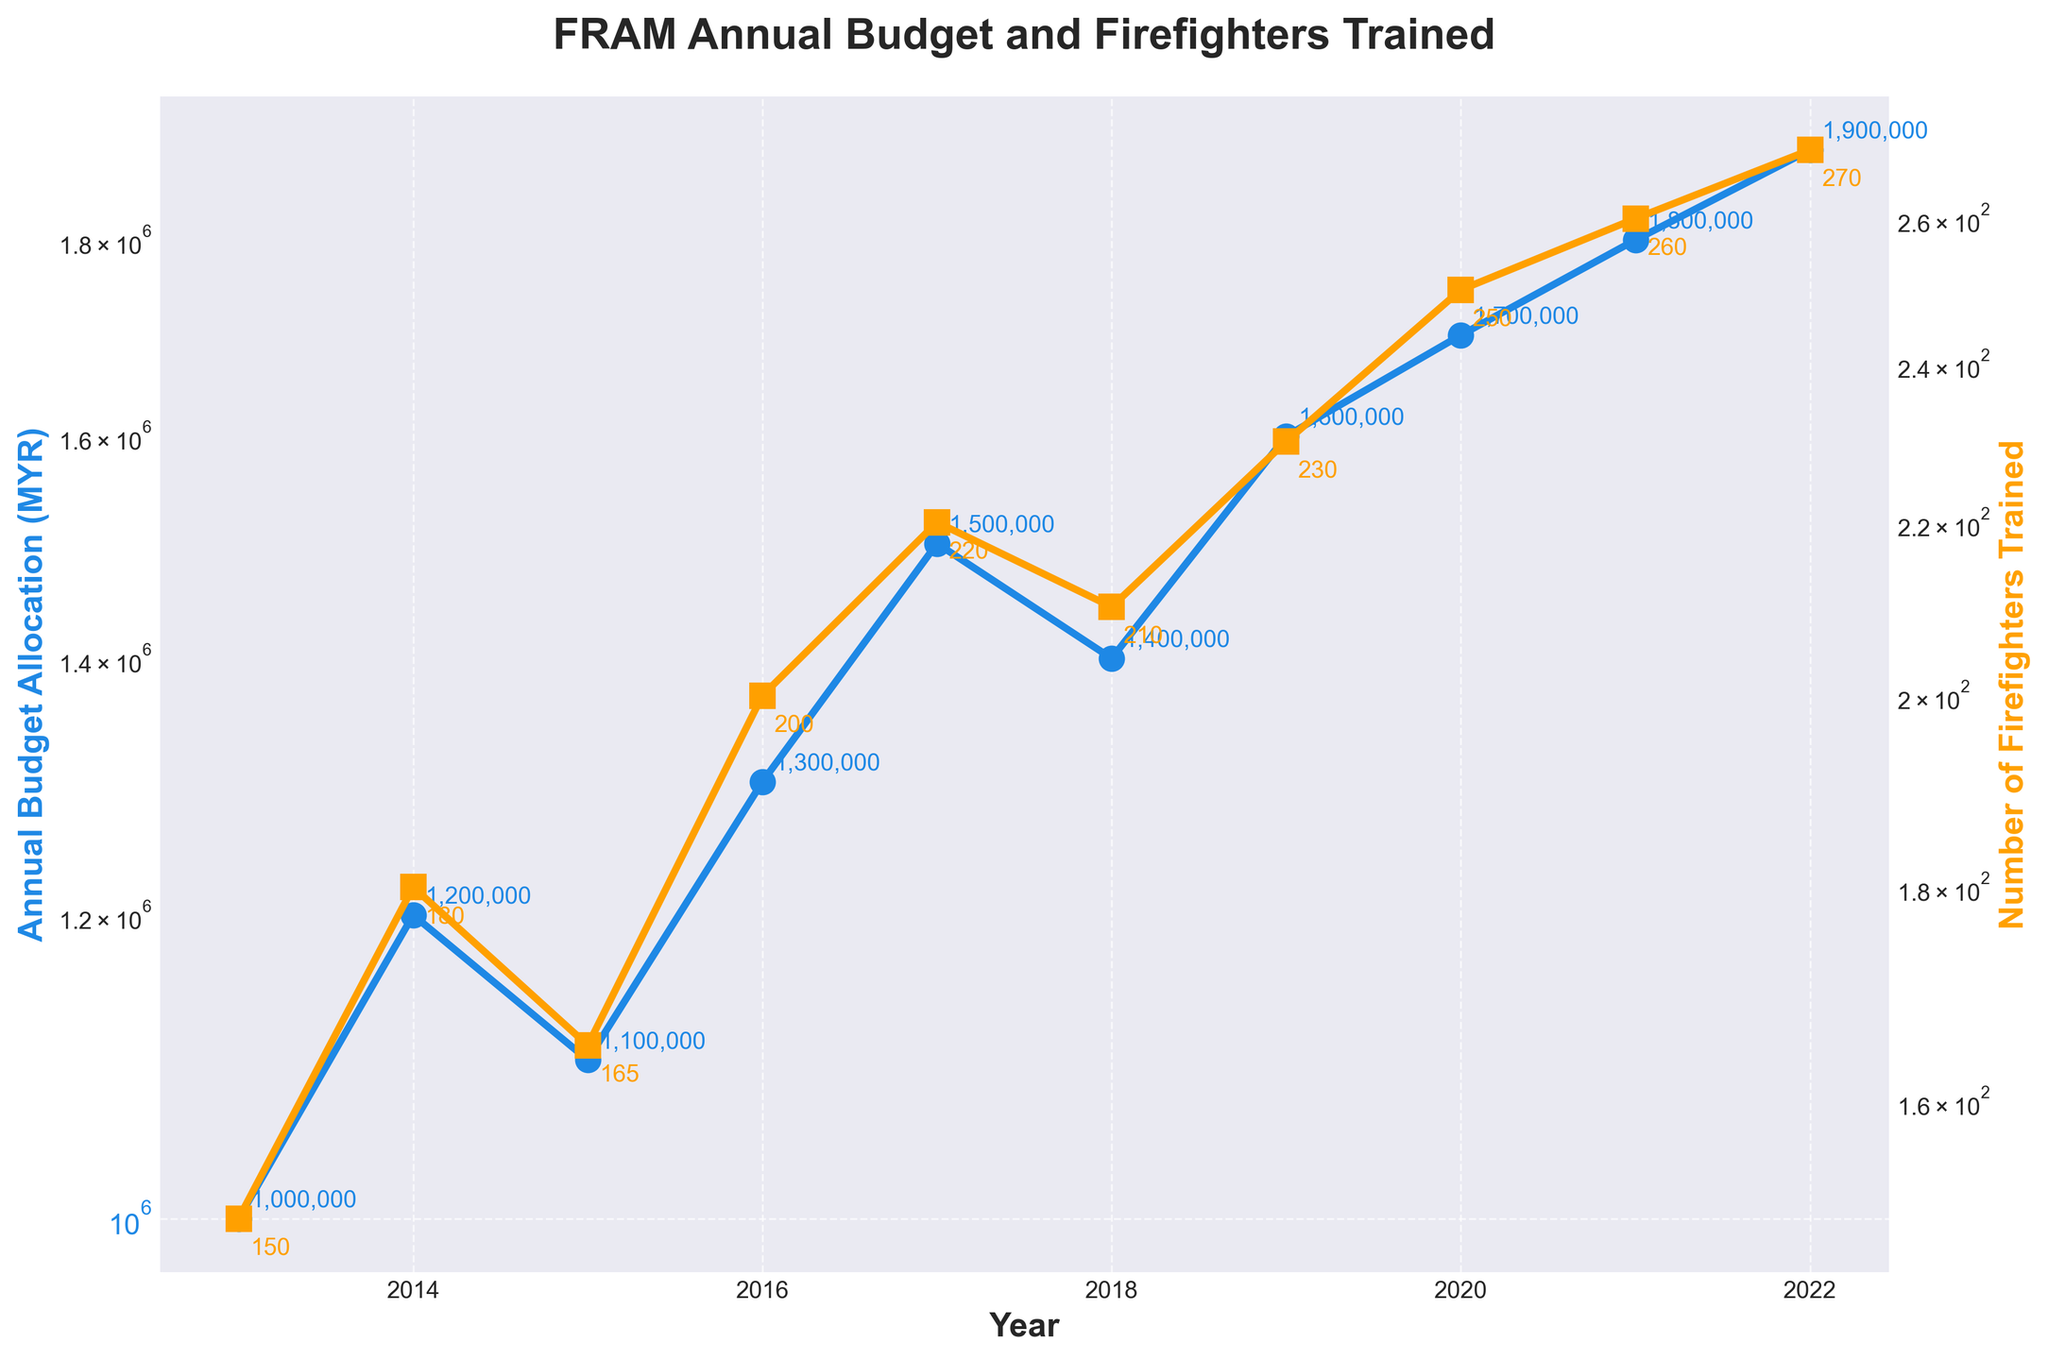What is the title of the figure? The title is centered at the top of the figure. It reads "FRAM Annual Budget and Firefighters Trained".
Answer: FRAM Annual Budget and Firefighters Trained How many data points are in the plot for each line? To find the number of data points, count the markers on either of the lines. Both lines consist of 10 data points.
Answer: 10 In which year did the Annual Budget Allocation reach 1.5 million MYR? Look for the point on the blue line where the y-axis reads 1.5 million MYR. This occurs in 2017.
Answer: 2017 How many firefighters were trained in 2019? Locate the green line on the second y-axis and find the point for the year 2019 on the x-axis. The corresponding value is 230.
Answer: 230 What is the trend in the Annual Budget Allocation from 2013 to 2022? Examine the blue line; it shows an upward trend from 1,000,000 MYR in 2013 to 1,900,000 MYR in 2022.
Answer: Upward trend Which year saw the highest number of firefighters trained? Identify the highest point on the yellow line. The highest number of firefighters trained was in 2022, with 270 firefighters.
Answer: 2022 How did the number of firefighters trained change between 2016 and 2017? Check the yellow line for the data points at 2016 and 2017. The number increased from 200 in 2016 to 220 in 2017.
Answer: Increased by 20 Compare the rate of increase in the Annual Budget Allocation between 2020 and 2021 with the rate of increase in the number of firefighters trained for the same period. Which increased more? The Annual Budget Allocation increased from 1,700,000 MYR in 2020 to 1,800,000 MYR in 2021 (an increase of 100,000 MYR). The number of firefighters trained increased from 250 in 2020 to 260 in 2021 (an increase of 10). Given that both variables are on a log scale, compare the multiplicative factors rather than absolute differences. The multiplicative factor for the budget is 1,800,000 / 1,700,000 ≈ 1.059 and for the firefighters is 260 / 250 = 1.04. The budget increased more proportionally.
Answer: Budget What is the percentage increase in the Annual Budget Allocation from 2013 to 2022? The budget in 2013 was 1,000,000 MYR and in 2022 it was 1,900,000 MYR. Percentage increase = ((1,900,000 - 1,000,000) / 1,000,000) * 100 = 90%.
Answer: 90% Why might the Annual Budget Allocation and the number of firefighters trained both be plotted on a log scale? Both budget and number of firefighters trained span a wide range of values. Using a log scale allows for better visualization of relative changes and proportional growths over time.
Answer: Wide range visualization 